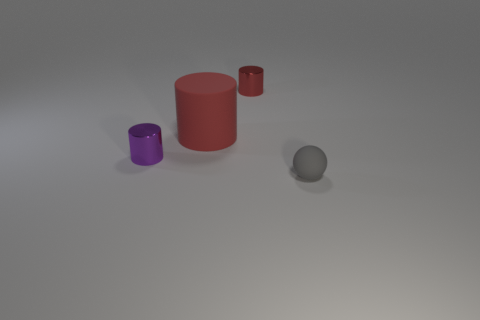Subtract all small purple cylinders. How many cylinders are left? 2 Add 3 red rubber things. How many objects exist? 7 Subtract all green spheres. How many red cylinders are left? 2 Subtract all red cylinders. How many cylinders are left? 1 Subtract 2 cylinders. How many cylinders are left? 1 Subtract all cylinders. How many objects are left? 1 Add 3 small gray rubber objects. How many small gray rubber objects exist? 4 Subtract 0 cyan spheres. How many objects are left? 4 Subtract all purple cylinders. Subtract all red spheres. How many cylinders are left? 2 Subtract all green cubes. Subtract all large red matte cylinders. How many objects are left? 3 